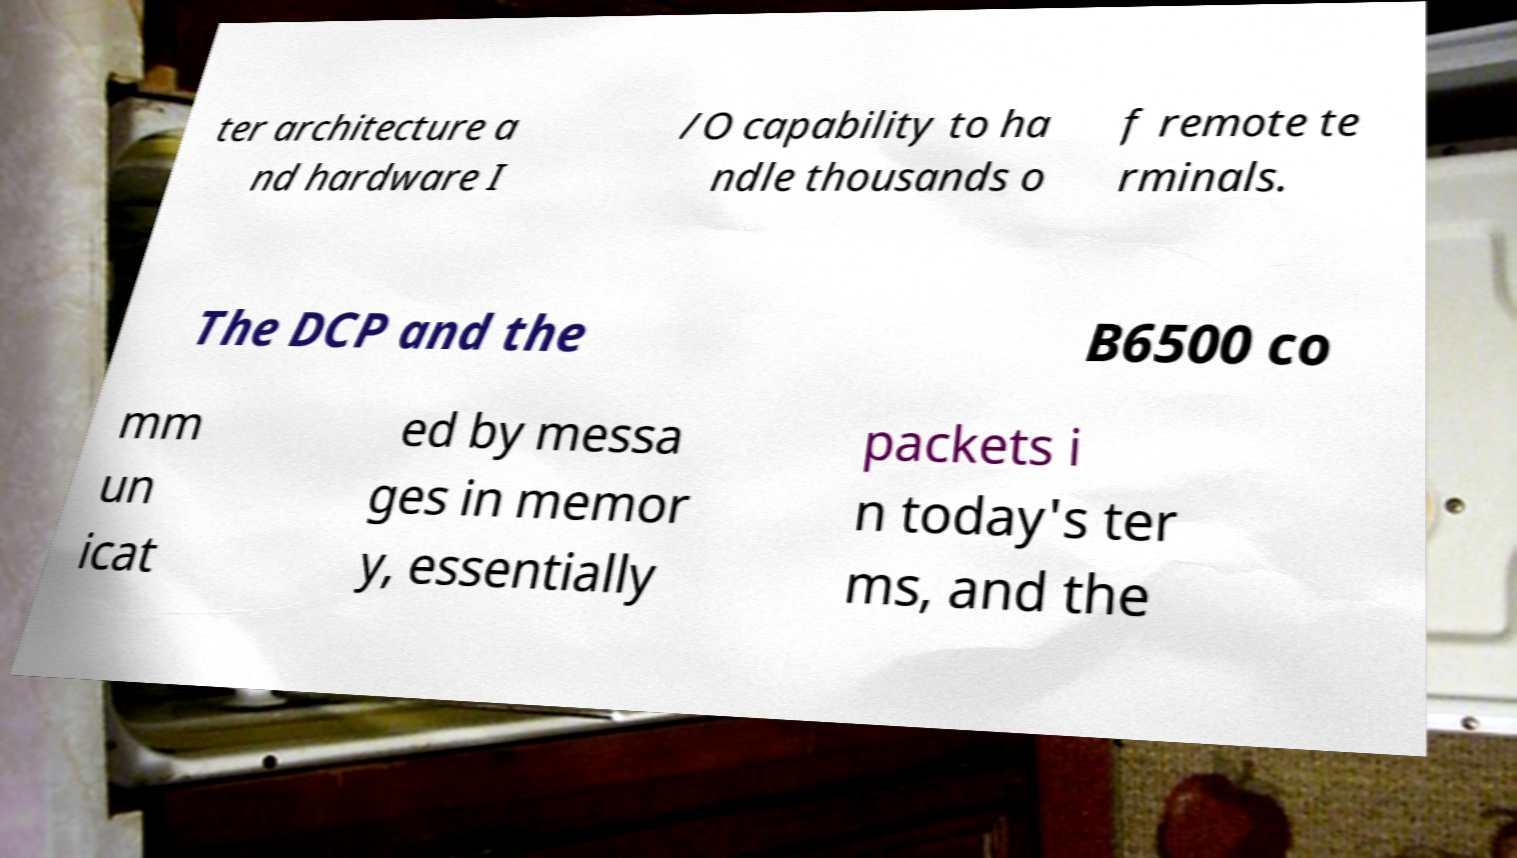Can you read and provide the text displayed in the image?This photo seems to have some interesting text. Can you extract and type it out for me? ter architecture a nd hardware I /O capability to ha ndle thousands o f remote te rminals. The DCP and the B6500 co mm un icat ed by messa ges in memor y, essentially packets i n today's ter ms, and the 